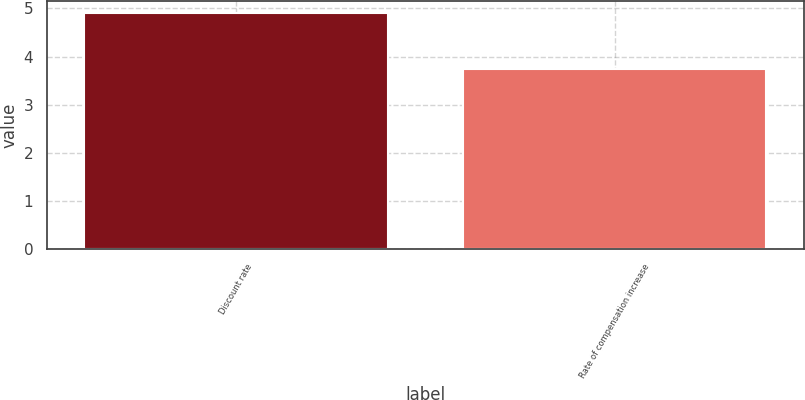Convert chart to OTSL. <chart><loc_0><loc_0><loc_500><loc_500><bar_chart><fcel>Discount rate<fcel>Rate of compensation increase<nl><fcel>4.9<fcel>3.75<nl></chart> 